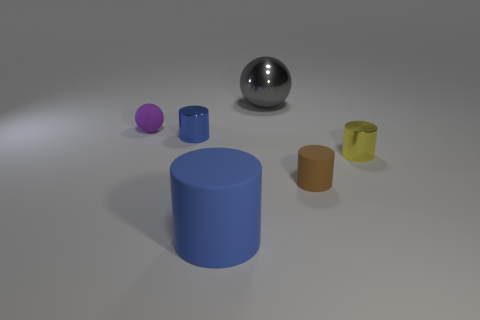Add 3 large shiny balls. How many objects exist? 9 Subtract all balls. How many objects are left? 4 Add 3 shiny things. How many shiny things are left? 6 Add 3 large blue cylinders. How many large blue cylinders exist? 4 Subtract 0 cyan cylinders. How many objects are left? 6 Subtract all large blue rubber things. Subtract all gray metal balls. How many objects are left? 4 